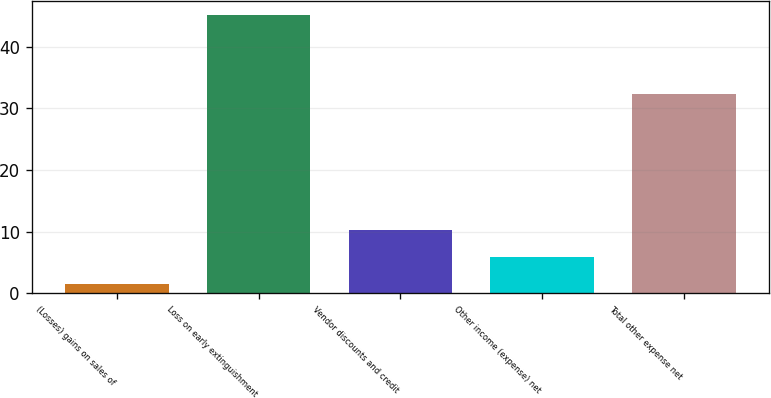Convert chart. <chart><loc_0><loc_0><loc_500><loc_500><bar_chart><fcel>(Losses) gains on sales of<fcel>Loss on early extinguishment<fcel>Vendor discounts and credit<fcel>Other income (expense) net<fcel>Total other expense net<nl><fcel>1.5<fcel>45.2<fcel>10.24<fcel>5.87<fcel>32.3<nl></chart> 